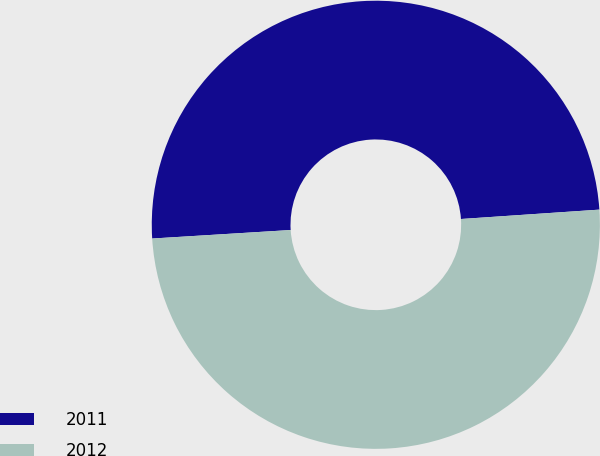Convert chart. <chart><loc_0><loc_0><loc_500><loc_500><pie_chart><fcel>2011<fcel>2012<nl><fcel>49.9%<fcel>50.1%<nl></chart> 